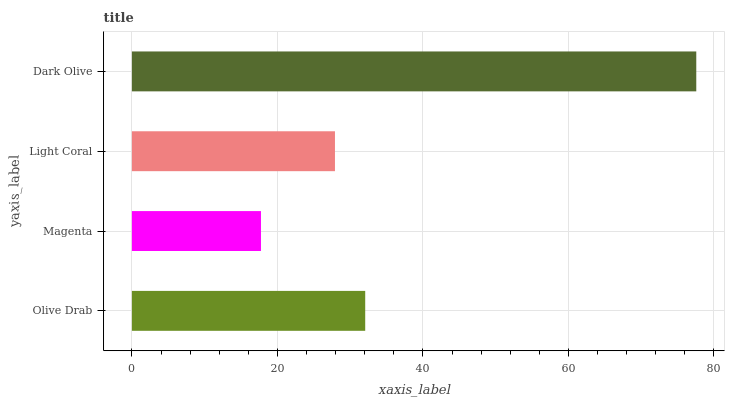Is Magenta the minimum?
Answer yes or no. Yes. Is Dark Olive the maximum?
Answer yes or no. Yes. Is Light Coral the minimum?
Answer yes or no. No. Is Light Coral the maximum?
Answer yes or no. No. Is Light Coral greater than Magenta?
Answer yes or no. Yes. Is Magenta less than Light Coral?
Answer yes or no. Yes. Is Magenta greater than Light Coral?
Answer yes or no. No. Is Light Coral less than Magenta?
Answer yes or no. No. Is Olive Drab the high median?
Answer yes or no. Yes. Is Light Coral the low median?
Answer yes or no. Yes. Is Dark Olive the high median?
Answer yes or no. No. Is Magenta the low median?
Answer yes or no. No. 